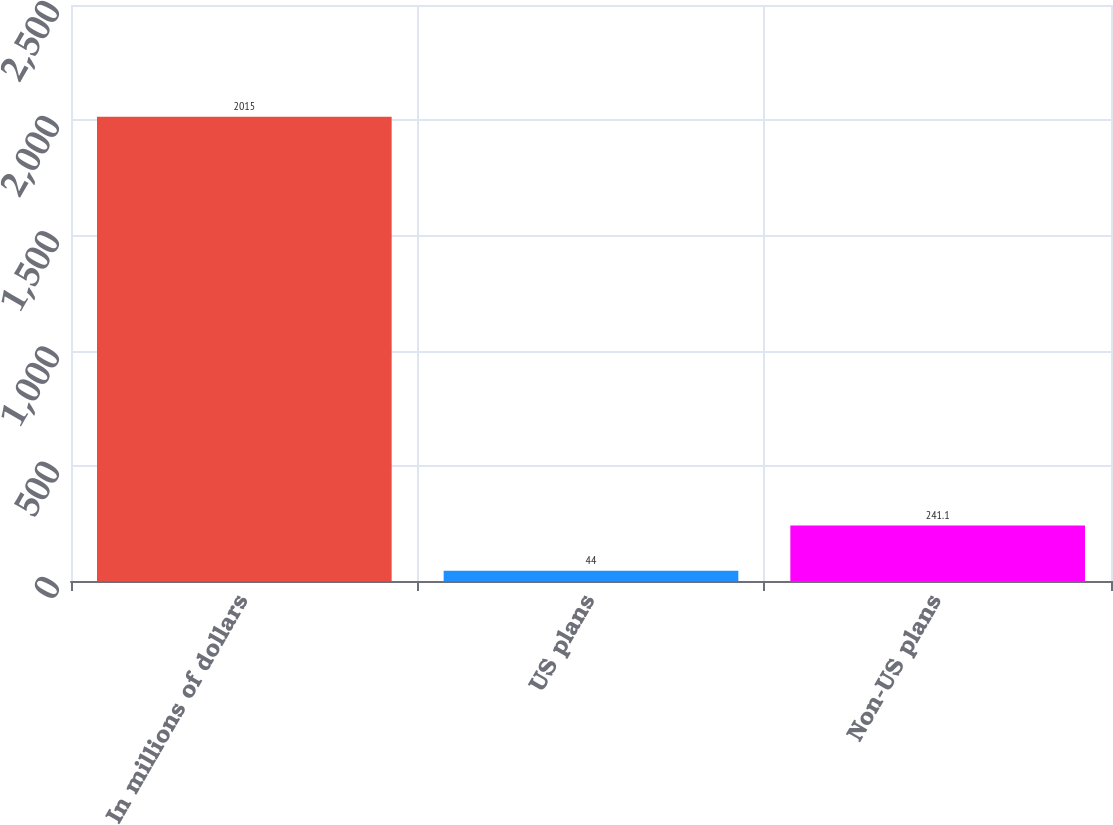<chart> <loc_0><loc_0><loc_500><loc_500><bar_chart><fcel>In millions of dollars<fcel>US plans<fcel>Non-US plans<nl><fcel>2015<fcel>44<fcel>241.1<nl></chart> 